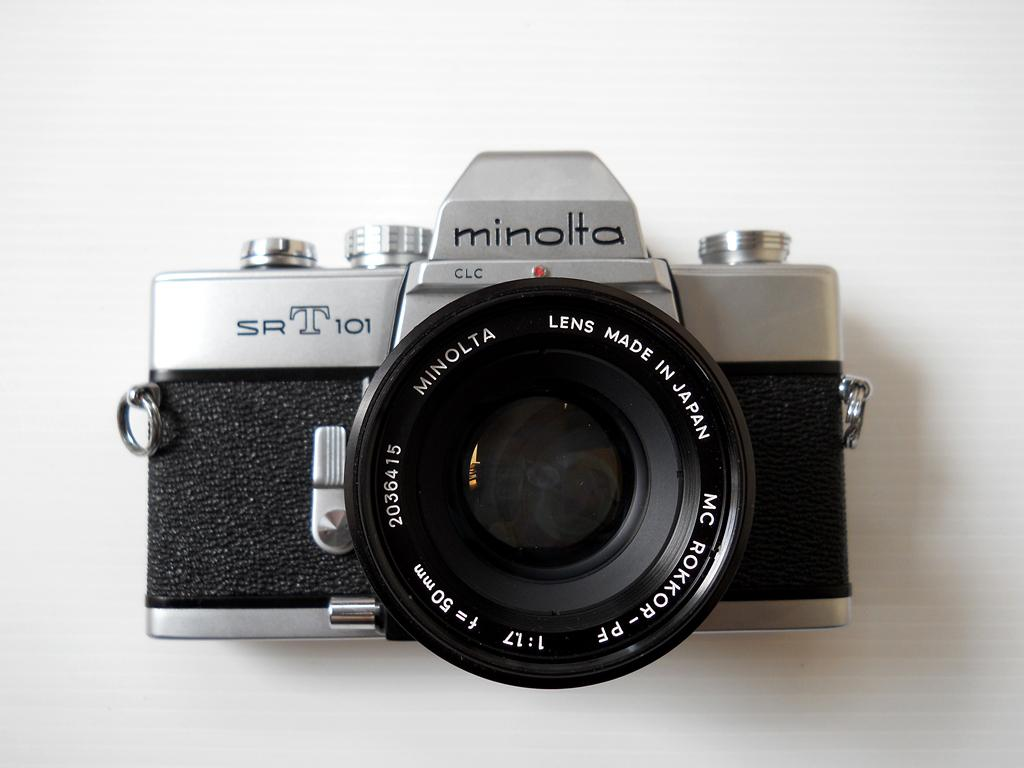<image>
Relay a brief, clear account of the picture shown. A Minolta camera sits on a white background with a made in Japan tag on its lense. 